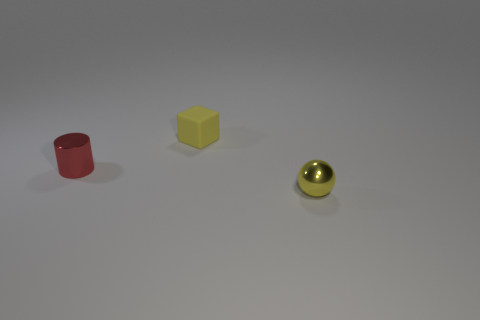Add 2 small objects. How many objects exist? 5 Subtract 0 blue spheres. How many objects are left? 3 Subtract all cylinders. How many objects are left? 2 Subtract all rubber blocks. Subtract all tiny red shiny things. How many objects are left? 1 Add 1 small yellow things. How many small yellow things are left? 3 Add 1 big green matte objects. How many big green matte objects exist? 1 